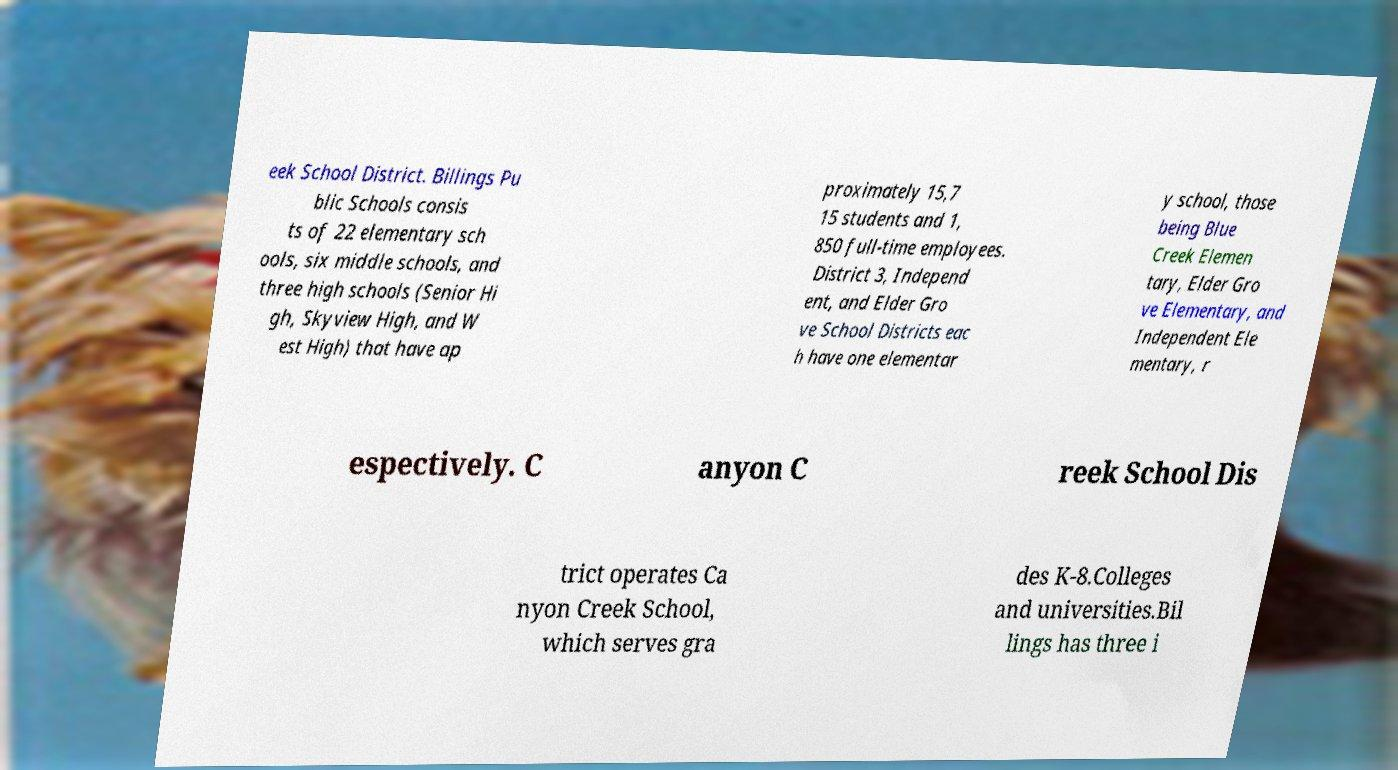What messages or text are displayed in this image? I need them in a readable, typed format. eek School District. Billings Pu blic Schools consis ts of 22 elementary sch ools, six middle schools, and three high schools (Senior Hi gh, Skyview High, and W est High) that have ap proximately 15,7 15 students and 1, 850 full-time employees. District 3, Independ ent, and Elder Gro ve School Districts eac h have one elementar y school, those being Blue Creek Elemen tary, Elder Gro ve Elementary, and Independent Ele mentary, r espectively. C anyon C reek School Dis trict operates Ca nyon Creek School, which serves gra des K-8.Colleges and universities.Bil lings has three i 